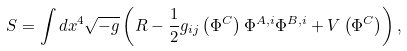Convert formula to latex. <formula><loc_0><loc_0><loc_500><loc_500>S = \int d x ^ { 4 } \sqrt { - g } \left ( R - \frac { 1 } { 2 } g _ { i j } \left ( \Phi ^ { C } \right ) \Phi ^ { A , i } \Phi ^ { B , i } + V \left ( \Phi ^ { C } \right ) \right ) ,</formula> 